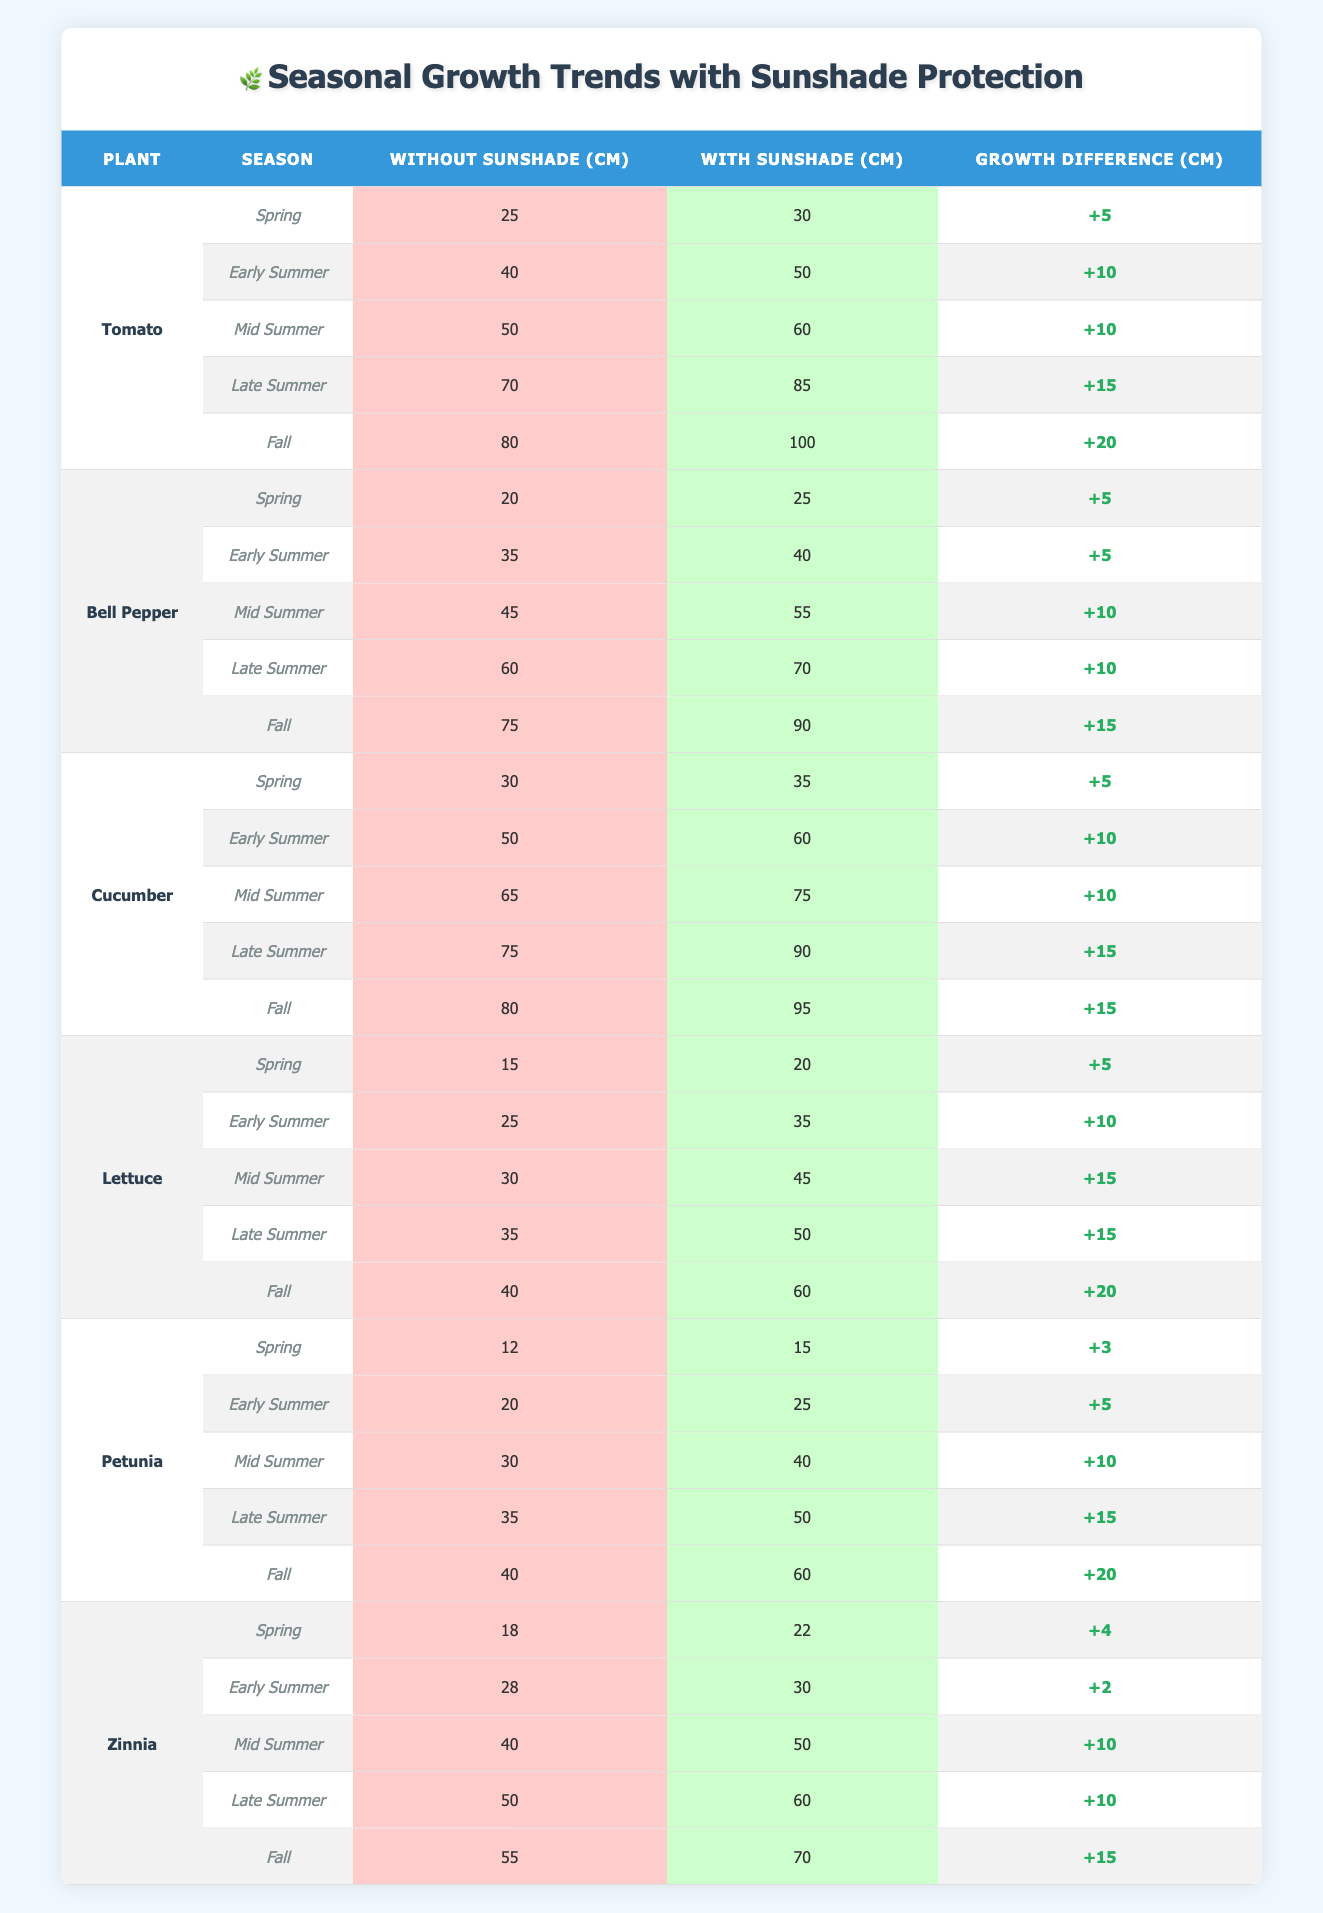What is the highest growth recorded for a plant with sunshade protection in Fall? The table shows that the highest recorded growth with sunshade protection is 100 cm for Tomato in Fall.
Answer: 100 cm In which season did Cucumber show the same growth with and without sunshade protection? By comparing the growth values, Cucumber showed the closest difference, but it did not show the same growth in any season; the closest difference is 5 cm in Spring.
Answer: None What is the total growth difference for Lettuce across all seasons? Lettuce has growth differences of +5, +10, +15, +15, and +20 cm. Adding these together gives 5 + 10 + 15 + 15 + 20 = 75 cm total difference.
Answer: 75 cm Which plant has the least growth increase from Spring to Fall when using sunshade protection? By comparing the growth increase for each plant, Petunia has a total increase from 15 cm in Spring to 60 cm in Fall, which is a 45 cm increase, the smallest relative increase among the plants listed.
Answer: Petunia What is the average growth across all plants with sunshade protection in Late Summer? For Late Summer, growth values are 85 (Tomato), 70 (Bell Pepper), 90 (Cucumber), 50 (Lettuce), 50 (Petunia), and 60 (Zinnia). Adding these (85 + 70 + 90 + 50 + 50 + 60) = 405 cm, then dividing by 6 gives an average of 67.5 cm.
Answer: 67.5 cm Did Tomato consistently outperform all other plants in growth with sunshade protection throughout the seasons? By reviewing the growth metrics, Tomato has the highest growth values in every season with sunshade protection compared to the other plants.
Answer: Yes What was the growth difference for Petunia during the Early Summer season? The growth without sunshade for Petunia in Early Summer is 20 cm, and with sunshade is 25 cm. The growth difference is calculated as 25 - 20 = 5 cm.
Answer: 5 cm Across all seasons, which plant benefits the most from sunshade protection in terms of growth difference? The total growth differences across seasons are +45 cm for Tomato, +40 cm for Bell Pepper, +50 cm for Cucumber, +60 cm for Lettuce, +53 cm for Petunia, and +41 cm for Zinnia. The maximum increase is 60 cm for Lettuce.
Answer: Lettuce What season shows the smallest growth without sunshade protection for any plant? Looking at the growth without sunshade values, Lettuce has the lowest growth of 15 cm in Spring.
Answer: Spring Which season showed the maximum difference in growth for any plant with sunshade protection? By comparing the growth with sunshade across seasons, the biggest difference for any plant is observed in Tomato from Fall (100 cm) to Spring (30 cm), resulting in a 70 cm maximum difference.
Answer: 70 cm In which season did Bell Pepper experience a growth difference of +5 cm? Checking the table, Bell Pepper has a growth difference of +5 cm in both Spring and Early Summer.
Answer: Spring and Early Summer 